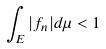<formula> <loc_0><loc_0><loc_500><loc_500>\int _ { E } | f _ { n } | d \mu < 1</formula> 